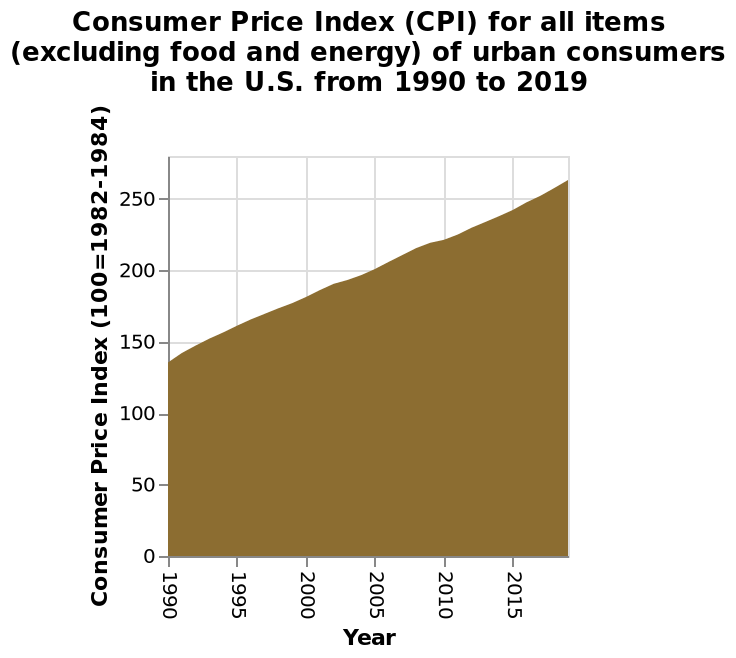<image>
During which years did the steepest rises in CPI occur? The steepest rises in CPI occurred from 1990 to 1995. please describe the details of the chart Here a is a area diagram called Consumer Price Index (CPI) for all items (excluding food and energy) of urban consumers in the U.S. from 1990 to 2019. On the x-axis, Year is measured. There is a linear scale with a minimum of 0 and a maximum of 250 on the y-axis, labeled Consumer Price Index (100=1982-1984). Which period experienced the highest increase in CPI? The period from 1990 to 1995 witnessed the highest increase in CPI. 